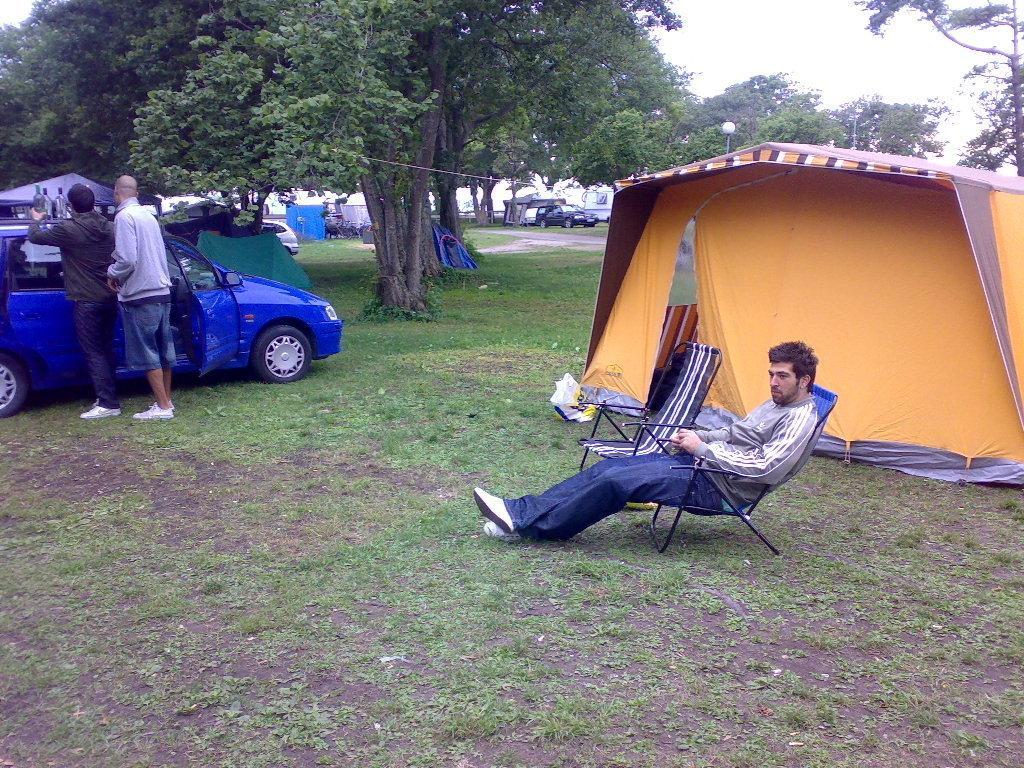Describe this image in one or two sentences. In the image there is a man sitting on a chair, behind him there is a tent and on the left side there is a car and in front of the car there are two men, there are some bottles kept on the car and beside the car there are trees and in the background there are some vehicles. 